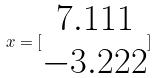Convert formula to latex. <formula><loc_0><loc_0><loc_500><loc_500>x = [ \begin{matrix} 7 . 1 1 1 \\ - 3 . 2 2 2 \end{matrix} ]</formula> 